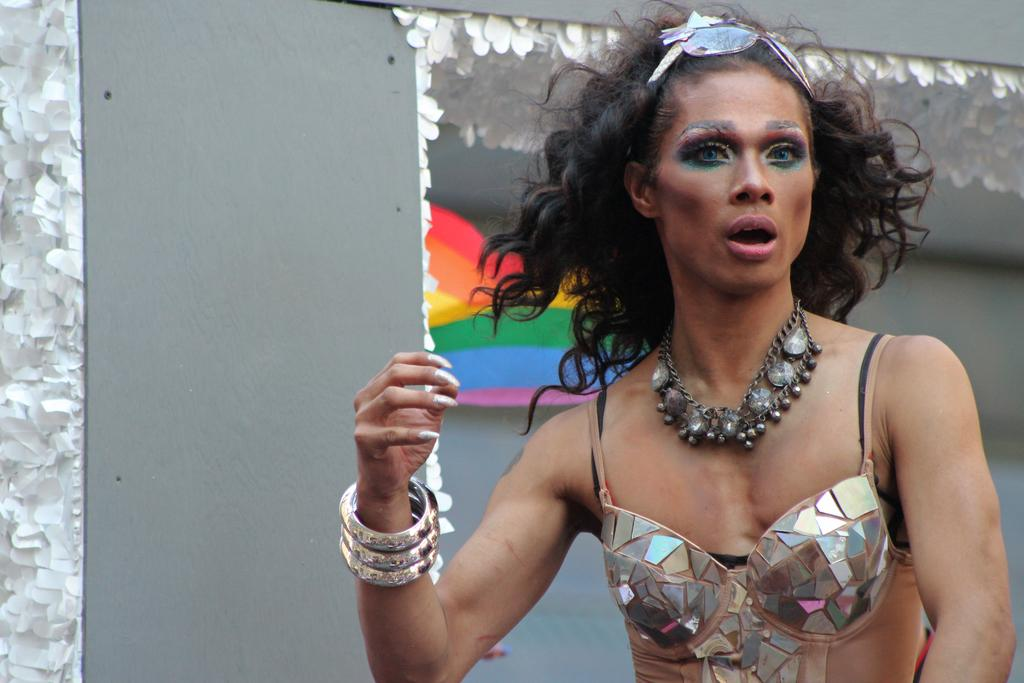What is the main subject of the image? There is a woman standing in the image. Can you describe the background of the image? There are decorative papers on a wall in the background of the image. What type of loaf can be seen in the image? There is no loaf present in the image. How does the woman in the image get the attention of the viewers? The image does not provide information about how the woman gets the attention of the viewers. 